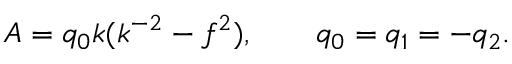Convert formula to latex. <formula><loc_0><loc_0><loc_500><loc_500>A = q _ { 0 } k ( k ^ { - 2 } - f ^ { 2 } ) , \quad \ \ q _ { 0 } = q _ { 1 } = - q _ { 2 } .</formula> 